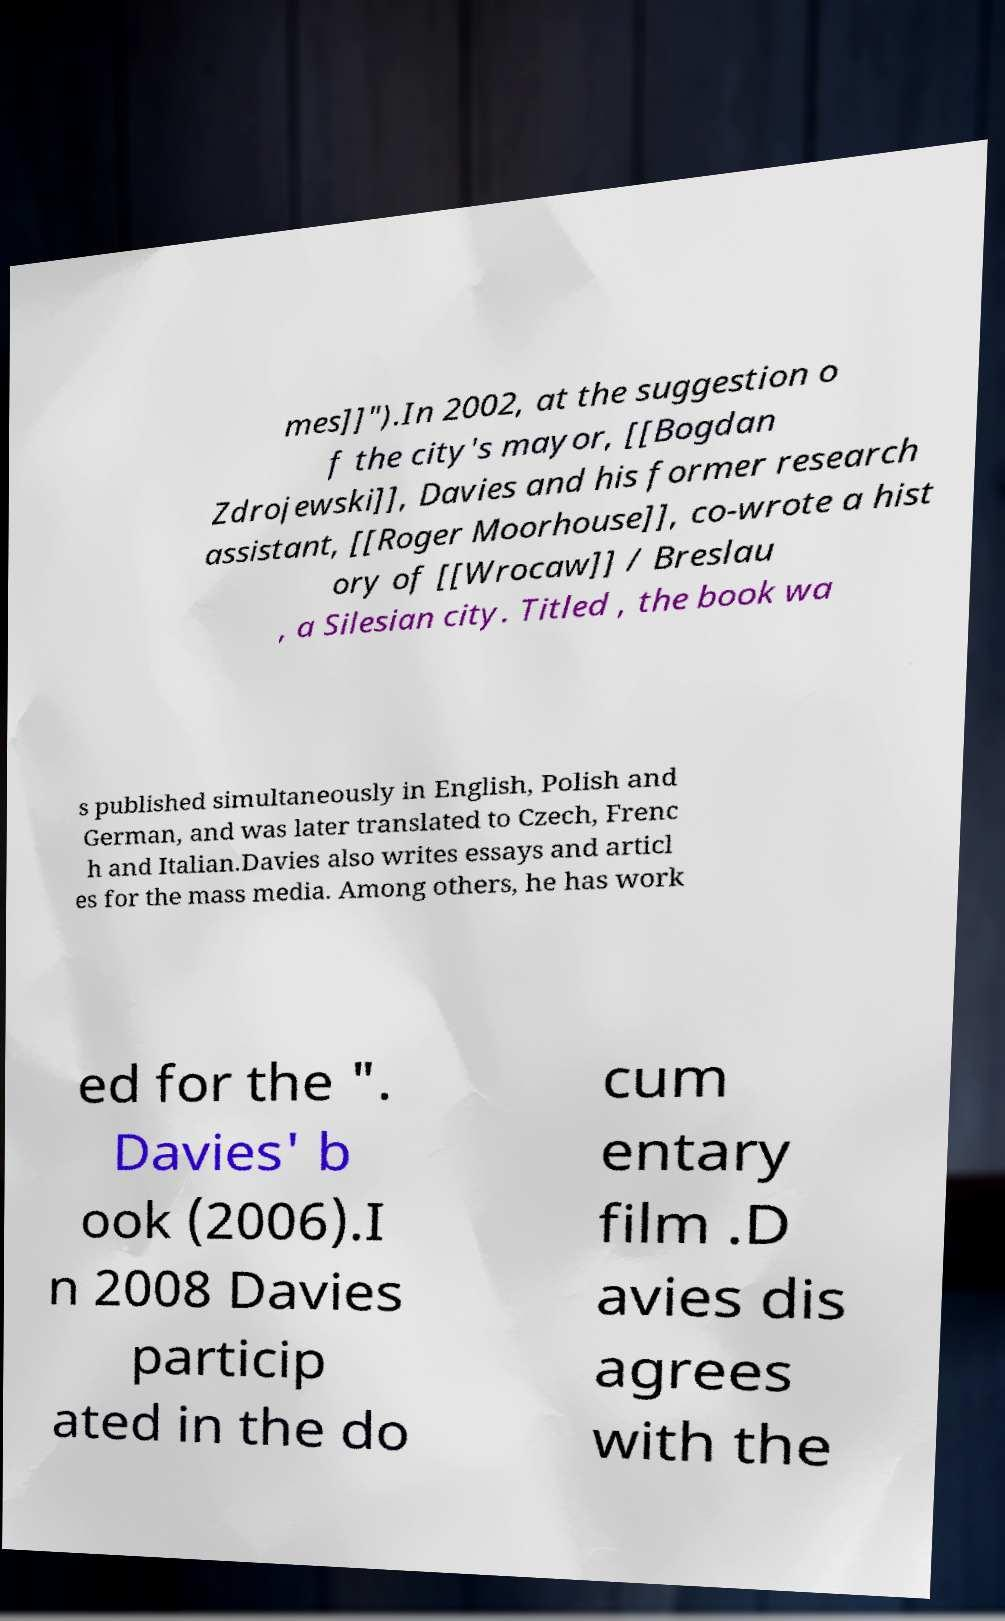Could you assist in decoding the text presented in this image and type it out clearly? mes]]").In 2002, at the suggestion o f the city's mayor, [[Bogdan Zdrojewski]], Davies and his former research assistant, [[Roger Moorhouse]], co-wrote a hist ory of [[Wrocaw]] / Breslau , a Silesian city. Titled , the book wa s published simultaneously in English, Polish and German, and was later translated to Czech, Frenc h and Italian.Davies also writes essays and articl es for the mass media. Among others, he has work ed for the ". Davies' b ook (2006).I n 2008 Davies particip ated in the do cum entary film .D avies dis agrees with the 